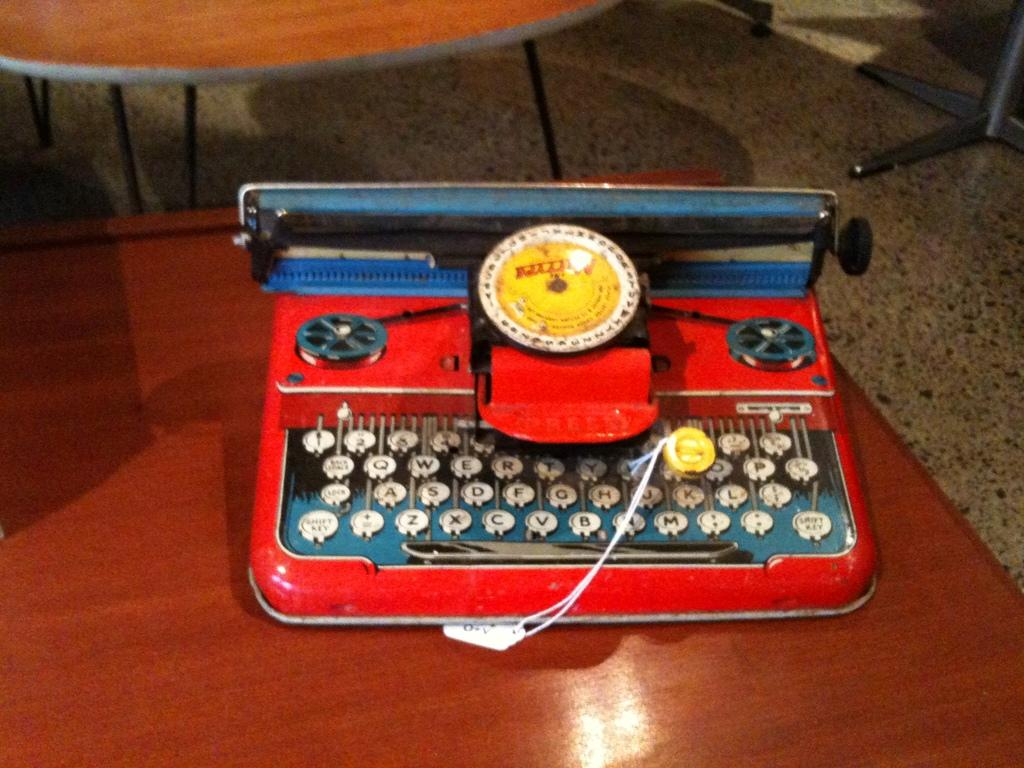<image>
Render a clear and concise summary of the photo. an old red typewriter on a table shows a keyboard with keys Q and W 